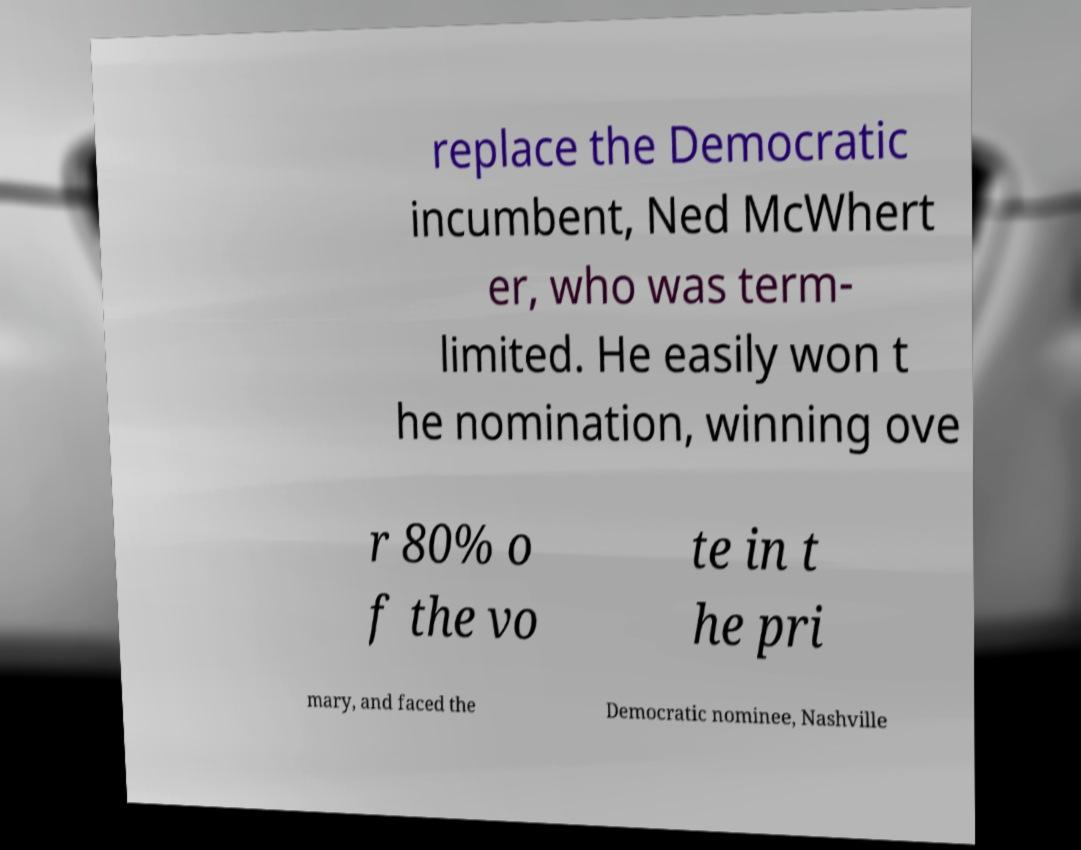Please identify and transcribe the text found in this image. replace the Democratic incumbent, Ned McWhert er, who was term- limited. He easily won t he nomination, winning ove r 80% o f the vo te in t he pri mary, and faced the Democratic nominee, Nashville 